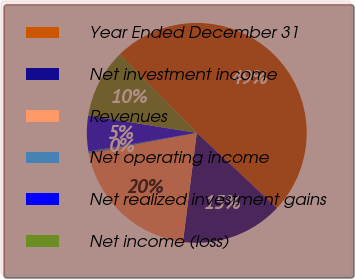<chart> <loc_0><loc_0><loc_500><loc_500><pie_chart><fcel>Year Ended December 31<fcel>Net investment income<fcel>Revenues<fcel>Net operating income<fcel>Net realized investment gains<fcel>Net income (loss)<nl><fcel>49.31%<fcel>15.03%<fcel>19.93%<fcel>0.34%<fcel>5.24%<fcel>10.14%<nl></chart> 